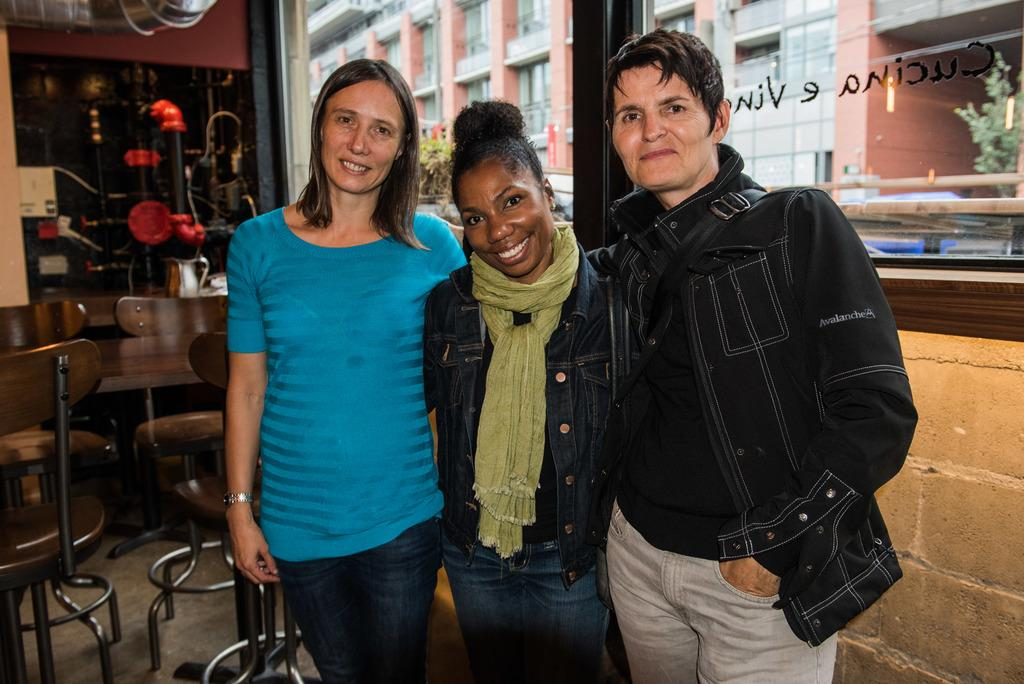How many people are in the image? There are three persons standing in the image. What objects are present for sitting? There are chairs in the image. What can be seen in the background of the image? A glass window, a building, and a tree are visible through the glass window. What type of shade is provided by the tree visible through the glass window? There is no mention of shade or any specific type of tree in the image, so it cannot be determined from the image. 